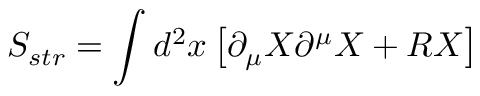<formula> <loc_0><loc_0><loc_500><loc_500>S _ { s t r } = \int d ^ { 2 } x \left [ \partial _ { \mu } X \partial ^ { \mu } X + R X \right ]</formula> 